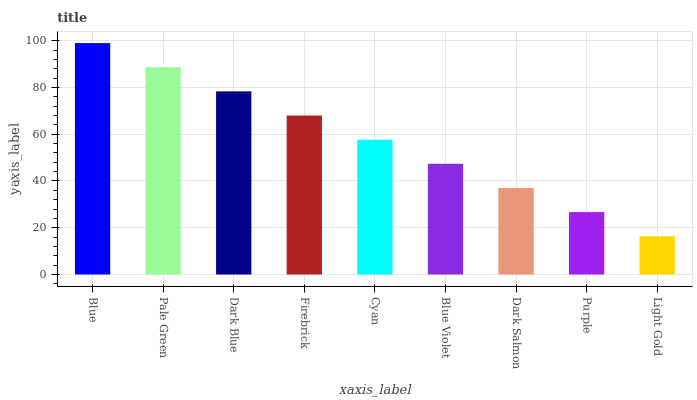Is Light Gold the minimum?
Answer yes or no. Yes. Is Blue the maximum?
Answer yes or no. Yes. Is Pale Green the minimum?
Answer yes or no. No. Is Pale Green the maximum?
Answer yes or no. No. Is Blue greater than Pale Green?
Answer yes or no. Yes. Is Pale Green less than Blue?
Answer yes or no. Yes. Is Pale Green greater than Blue?
Answer yes or no. No. Is Blue less than Pale Green?
Answer yes or no. No. Is Cyan the high median?
Answer yes or no. Yes. Is Cyan the low median?
Answer yes or no. Yes. Is Blue the high median?
Answer yes or no. No. Is Light Gold the low median?
Answer yes or no. No. 